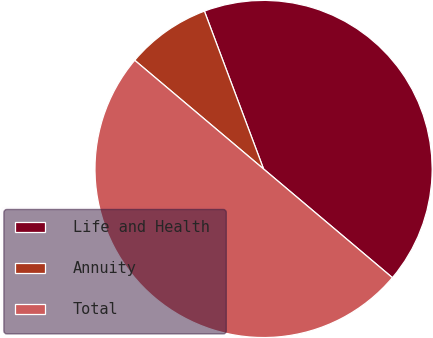Convert chart. <chart><loc_0><loc_0><loc_500><loc_500><pie_chart><fcel>Life and Health<fcel>Annuity<fcel>Total<nl><fcel>41.86%<fcel>8.14%<fcel>50.0%<nl></chart> 